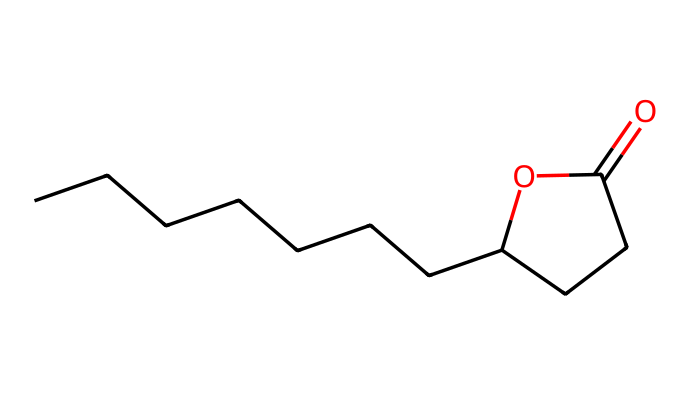What is the IUPAC name of the chemical represented by this SMILES? Analyzing the SMILES structure reveals that the longest carbon chain contains ten carbon atoms with a lactone functional group indicated by the cyclic structure. Thus, the IUPAC name is gamma-decalactone.
Answer: gamma-decalactone How many carbon atoms are present in gamma-decalactone? Counting each carbon atom in the structure represented by the SMILES shows there are ten carbon atoms.
Answer: ten What functional group is present in gamma-decalactone? The structure features a cyclic ester functional group, which is characteristic of lactones, specifically indicated by the presence of the carbonyl (C=O) and the ether-like oxygen in the ring.
Answer: lactone What is the molecular formula of gamma-decalactone? By counting the elements in the chemical, the number of carbons (C), hydrogens (H), and oxygens (O) gives the molecular formula C10H18O2.
Answer: C10H18O2 What characteristic scent is associated with gamma-decalactone? Gamma-decalactone is well-known for imparting a comforting peach fragrance, often used in scented products such as candles.
Answer: peach Does gamma-decalactone have any applications beyond fragrances? Beyond fragrance applications, gamma-decalactone is also utilized in flavoring foods and beverages, in addition to its role as a scent in cosmetics.
Answer: yes What type of compound is gamma-decalactone primarily categorized as? Gamma-decalactone is categorized primarily as a flavor and fragrance compound due to its ability to provide sensory attributes in various applications, typical of esters.
Answer: ester 